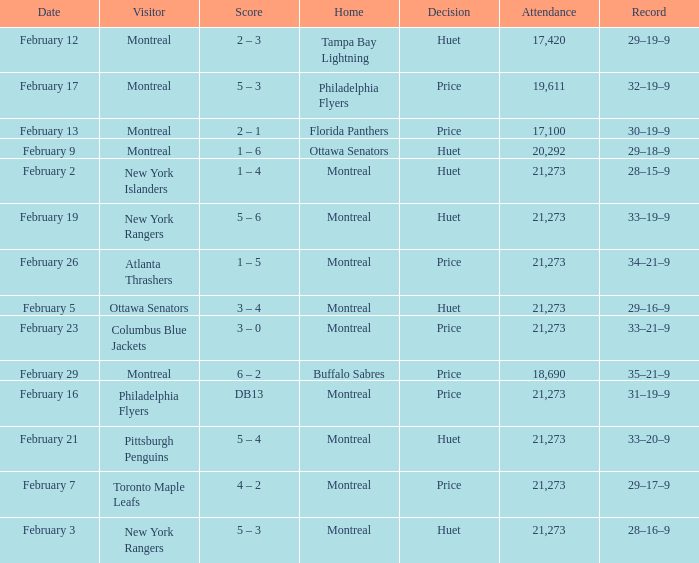Who was the visiting team at the game when the Canadiens had a record of 30–19–9? Montreal. 